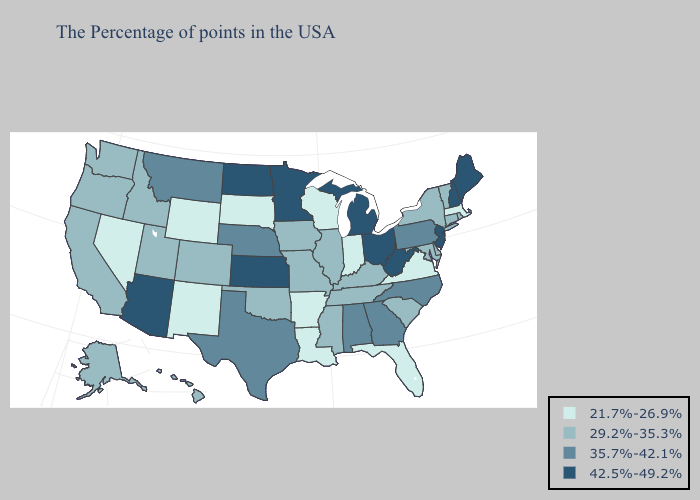Name the states that have a value in the range 29.2%-35.3%?
Quick response, please. Rhode Island, Vermont, Connecticut, New York, Delaware, Maryland, South Carolina, Kentucky, Tennessee, Illinois, Mississippi, Missouri, Iowa, Oklahoma, Colorado, Utah, Idaho, California, Washington, Oregon, Alaska, Hawaii. Name the states that have a value in the range 29.2%-35.3%?
Keep it brief. Rhode Island, Vermont, Connecticut, New York, Delaware, Maryland, South Carolina, Kentucky, Tennessee, Illinois, Mississippi, Missouri, Iowa, Oklahoma, Colorado, Utah, Idaho, California, Washington, Oregon, Alaska, Hawaii. Among the states that border Minnesota , does Iowa have the lowest value?
Keep it brief. No. What is the lowest value in the South?
Quick response, please. 21.7%-26.9%. Among the states that border Tennessee , does Arkansas have the highest value?
Answer briefly. No. Name the states that have a value in the range 29.2%-35.3%?
Be succinct. Rhode Island, Vermont, Connecticut, New York, Delaware, Maryland, South Carolina, Kentucky, Tennessee, Illinois, Mississippi, Missouri, Iowa, Oklahoma, Colorado, Utah, Idaho, California, Washington, Oregon, Alaska, Hawaii. Which states have the lowest value in the West?
Keep it brief. Wyoming, New Mexico, Nevada. Name the states that have a value in the range 42.5%-49.2%?
Answer briefly. Maine, New Hampshire, New Jersey, West Virginia, Ohio, Michigan, Minnesota, Kansas, North Dakota, Arizona. Name the states that have a value in the range 21.7%-26.9%?
Be succinct. Massachusetts, Virginia, Florida, Indiana, Wisconsin, Louisiana, Arkansas, South Dakota, Wyoming, New Mexico, Nevada. Among the states that border Delaware , does Pennsylvania have the highest value?
Concise answer only. No. Does Indiana have the highest value in the MidWest?
Keep it brief. No. Which states have the lowest value in the MidWest?
Concise answer only. Indiana, Wisconsin, South Dakota. Does the first symbol in the legend represent the smallest category?
Quick response, please. Yes. Name the states that have a value in the range 29.2%-35.3%?
Keep it brief. Rhode Island, Vermont, Connecticut, New York, Delaware, Maryland, South Carolina, Kentucky, Tennessee, Illinois, Mississippi, Missouri, Iowa, Oklahoma, Colorado, Utah, Idaho, California, Washington, Oregon, Alaska, Hawaii. Does Louisiana have a lower value than Washington?
Keep it brief. Yes. 